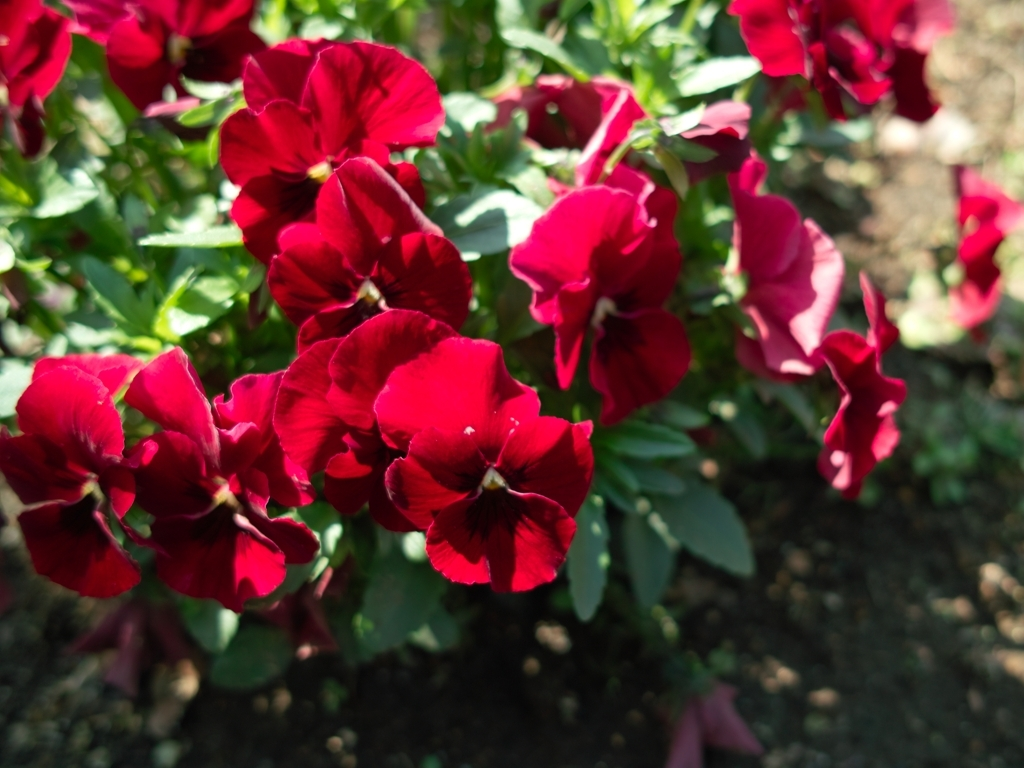Does the image have vibrant colors? Certainly, the image showcases a collection of flowers with deep and rich red petals that stand out amid the more subdued greens of the leaves and the earthy tones of the soil, creating a visually striking effect. 